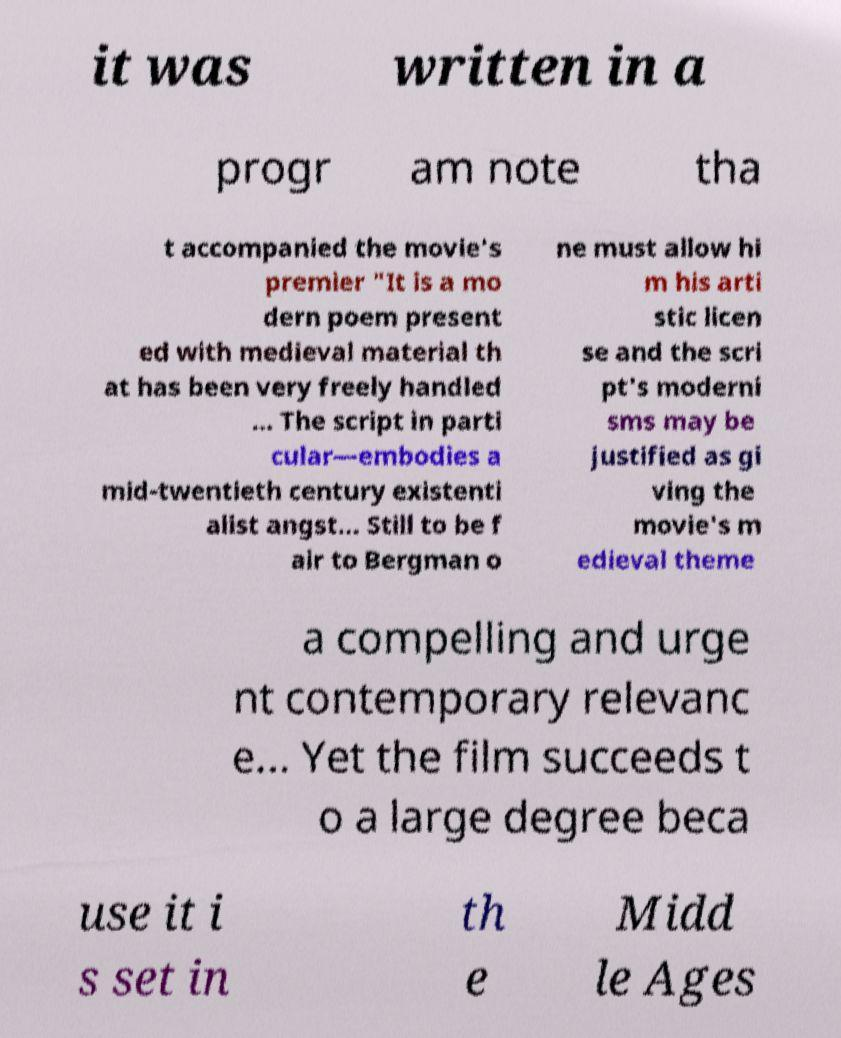Please read and relay the text visible in this image. What does it say? it was written in a progr am note tha t accompanied the movie's premier "It is a mo dern poem present ed with medieval material th at has been very freely handled ... The script in parti cular—embodies a mid-twentieth century existenti alist angst... Still to be f air to Bergman o ne must allow hi m his arti stic licen se and the scri pt's moderni sms may be justified as gi ving the movie's m edieval theme a compelling and urge nt contemporary relevanc e... Yet the film succeeds t o a large degree beca use it i s set in th e Midd le Ages 